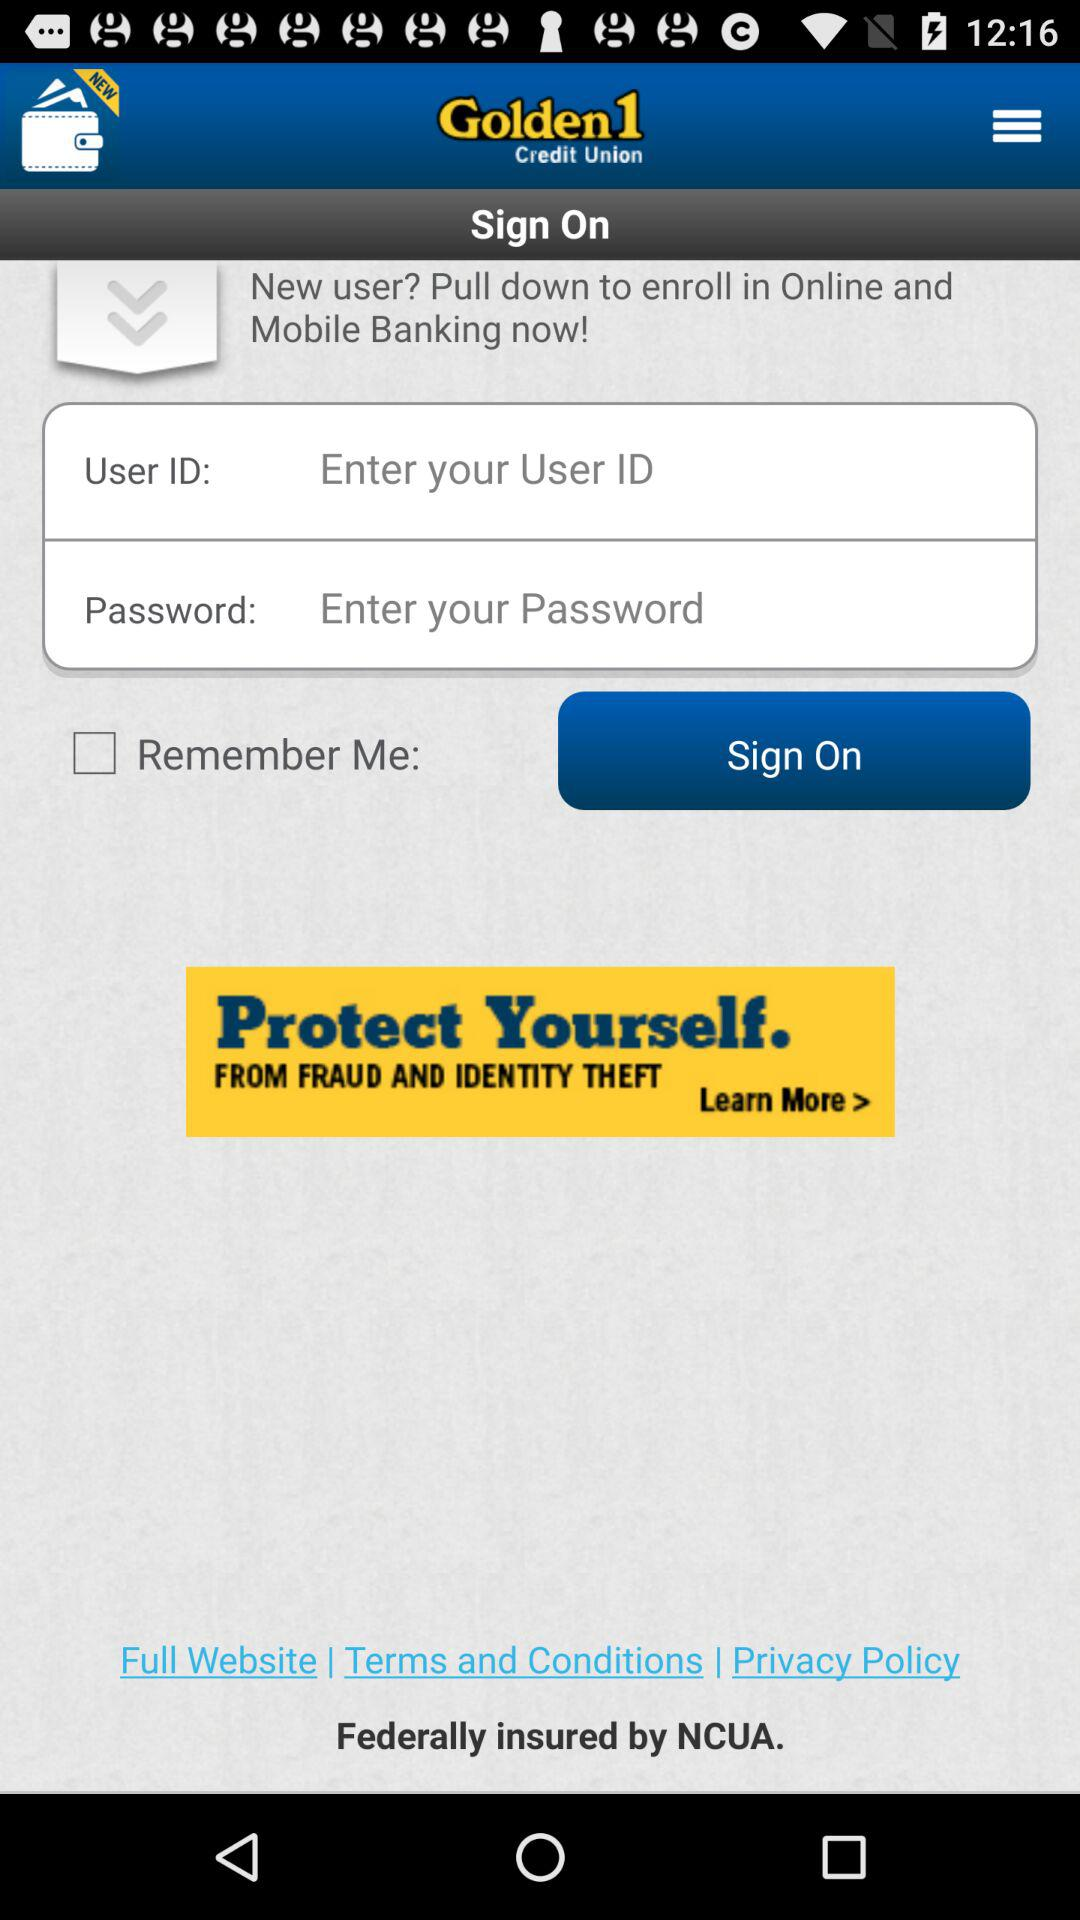How many text fields are there on this screen?
Answer the question using a single word or phrase. 2 